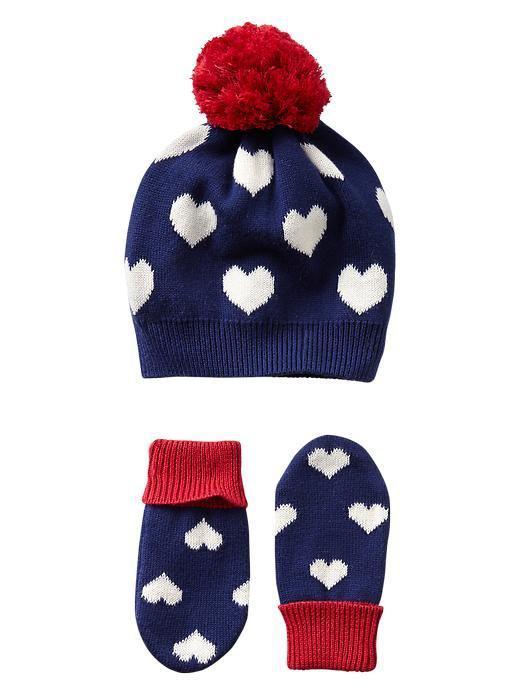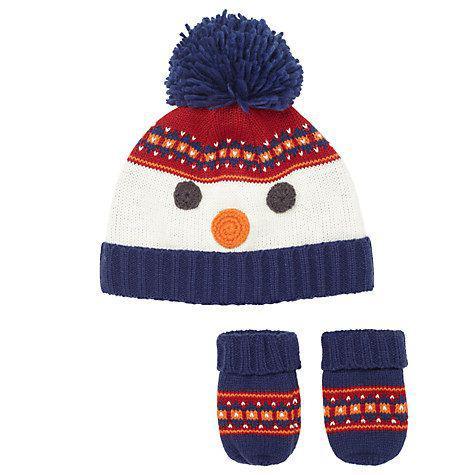The first image is the image on the left, the second image is the image on the right. Assess this claim about the two images: "Exactly two knit hats are multicolor with a ribbed bottom and a pompon on top, with a set of matching mittens shown below the hat.". Correct or not? Answer yes or no. Yes. 